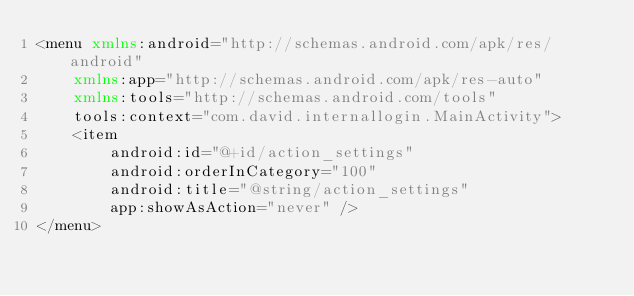<code> <loc_0><loc_0><loc_500><loc_500><_XML_><menu xmlns:android="http://schemas.android.com/apk/res/android"
    xmlns:app="http://schemas.android.com/apk/res-auto"
    xmlns:tools="http://schemas.android.com/tools"
    tools:context="com.david.internallogin.MainActivity">
    <item
        android:id="@+id/action_settings"
        android:orderInCategory="100"
        android:title="@string/action_settings"
        app:showAsAction="never" />
</menu></code> 